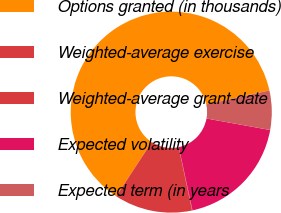Convert chart. <chart><loc_0><loc_0><loc_500><loc_500><pie_chart><fcel>Options granted (in thousands)<fcel>Weighted-average exercise<fcel>Weighted-average grant-date<fcel>Expected volatility<fcel>Expected term (in years<nl><fcel>62.32%<fcel>12.53%<fcel>0.08%<fcel>18.76%<fcel>6.31%<nl></chart> 